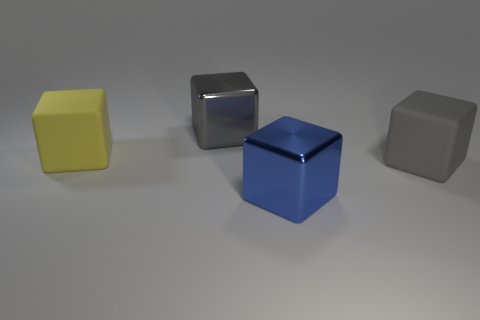Are there an equal number of large blue metal blocks that are behind the large blue metal block and large yellow matte objects in front of the large gray metal block?
Your answer should be compact. No. What is the object that is both in front of the gray shiny cube and behind the large gray rubber thing made of?
Provide a succinct answer. Rubber. What number of other objects are there of the same size as the blue shiny block?
Your answer should be compact. 3. There is a object that is behind the large yellow block; is it the same color as the rubber block that is to the right of the yellow thing?
Keep it short and to the point. Yes. What size is the yellow matte thing?
Provide a short and direct response. Large. There is a gray block that is in front of the yellow thing; what size is it?
Your response must be concise. Large. There is a big thing that is on the left side of the large gray matte thing and in front of the big yellow cube; what is its shape?
Offer a terse response. Cube. What number of other objects are there of the same shape as the large blue thing?
Your response must be concise. 3. There is another shiny cube that is the same size as the blue metal cube; what color is it?
Make the answer very short. Gray. How many objects are either blue cubes or yellow cubes?
Provide a succinct answer. 2. 